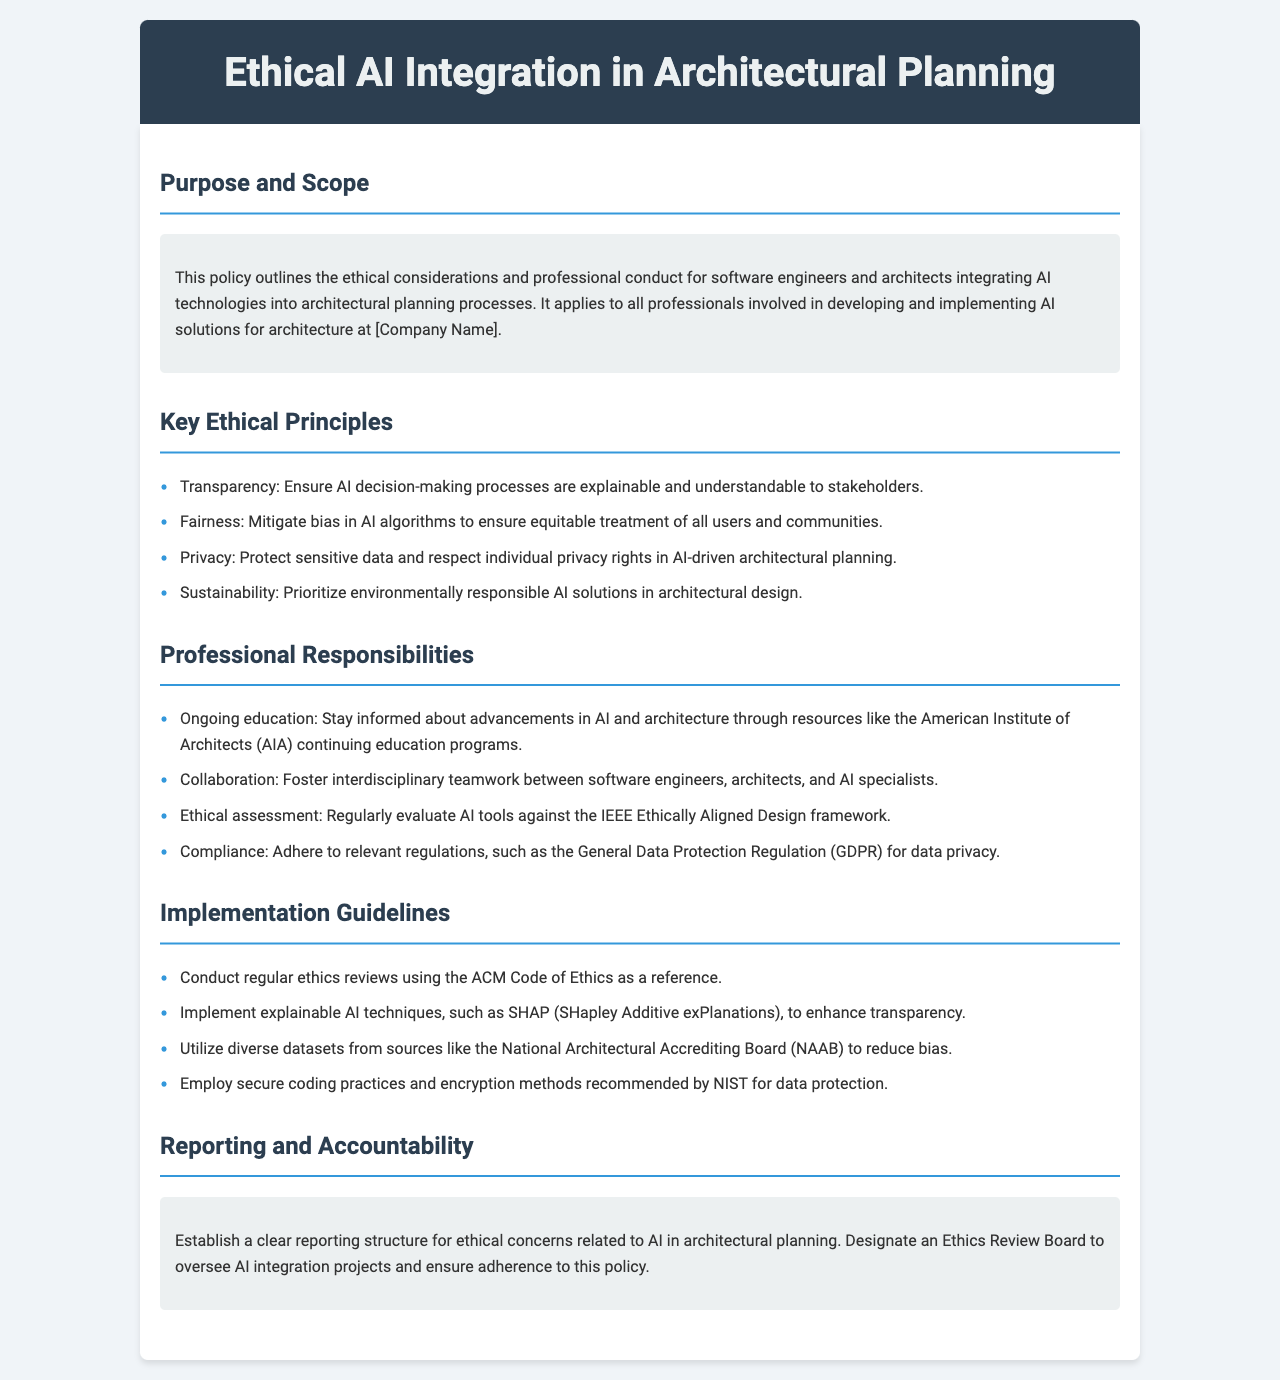What is the title of the document? The title is prominently displayed at the top of the document.
Answer: Ethical AI Integration in Architectural Planning What is the primary audience for this policy? The audience is specified in the purpose section, indicating who the policy applies to.
Answer: Software engineers and architects How many key ethical principles are outlined? The number of principles can be counted in the key ethical principles section.
Answer: Four What framework is suggested for ethical assessment? A specific framework is mentioned for evaluating AI tools in the professional responsibilities section.
Answer: IEEE Ethically Aligned Design What should be prioritized in architectural design according to the key ethical principles? The principles list includes an aspect that focuses on environmental impact.
Answer: Sustainability What organization offers continuing education programs mentioned in the document? An organization is mentioned that provides educational resources for professionals.
Answer: American Institute of Architects What is the purpose of the Ethics Review Board? The purpose is described in the reporting and accountability section, focusing on a specific oversight role.
Answer: Oversee AI integration projects What technique is recommended to enhance transparency in AI? A specific method is mentioned under the implementation guidelines.
Answer: SHAP (SHapley Additive exPlanations) Which regulation must be adhered to regarding data privacy? A regulation is explicitly noted under the professional responsibilities section.
Answer: General Data Protection Regulation (GDPR) 